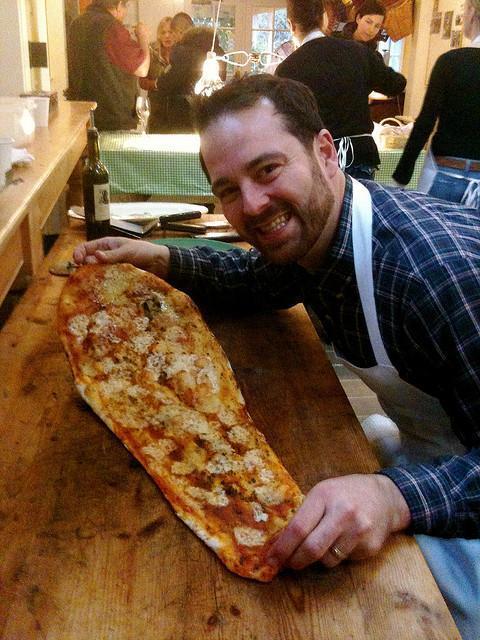How many people are in this picture?
Give a very brief answer. 7. How many dining tables are there?
Give a very brief answer. 1. How many people are there?
Give a very brief answer. 5. How many pizzas are there?
Give a very brief answer. 1. 